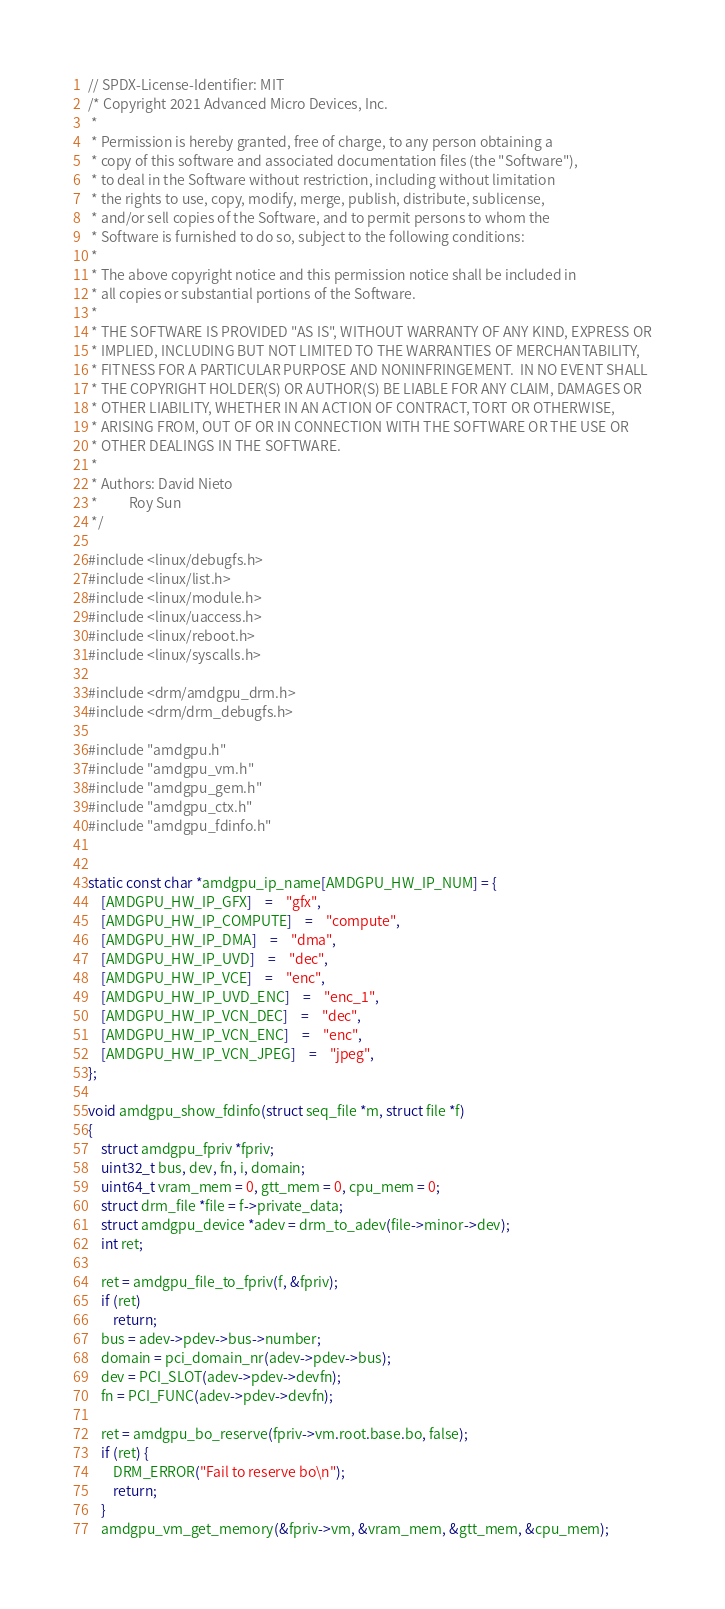<code> <loc_0><loc_0><loc_500><loc_500><_C_>// SPDX-License-Identifier: MIT
/* Copyright 2021 Advanced Micro Devices, Inc.
 *
 * Permission is hereby granted, free of charge, to any person obtaining a
 * copy of this software and associated documentation files (the "Software"),
 * to deal in the Software without restriction, including without limitation
 * the rights to use, copy, modify, merge, publish, distribute, sublicense,
 * and/or sell copies of the Software, and to permit persons to whom the
 * Software is furnished to do so, subject to the following conditions:
 *
 * The above copyright notice and this permission notice shall be included in
 * all copies or substantial portions of the Software.
 *
 * THE SOFTWARE IS PROVIDED "AS IS", WITHOUT WARRANTY OF ANY KIND, EXPRESS OR
 * IMPLIED, INCLUDING BUT NOT LIMITED TO THE WARRANTIES OF MERCHANTABILITY,
 * FITNESS FOR A PARTICULAR PURPOSE AND NONINFRINGEMENT.  IN NO EVENT SHALL
 * THE COPYRIGHT HOLDER(S) OR AUTHOR(S) BE LIABLE FOR ANY CLAIM, DAMAGES OR
 * OTHER LIABILITY, WHETHER IN AN ACTION OF CONTRACT, TORT OR OTHERWISE,
 * ARISING FROM, OUT OF OR IN CONNECTION WITH THE SOFTWARE OR THE USE OR
 * OTHER DEALINGS IN THE SOFTWARE.
 *
 * Authors: David Nieto
 *          Roy Sun
 */

#include <linux/debugfs.h>
#include <linux/list.h>
#include <linux/module.h>
#include <linux/uaccess.h>
#include <linux/reboot.h>
#include <linux/syscalls.h>

#include <drm/amdgpu_drm.h>
#include <drm/drm_debugfs.h>

#include "amdgpu.h"
#include "amdgpu_vm.h"
#include "amdgpu_gem.h"
#include "amdgpu_ctx.h"
#include "amdgpu_fdinfo.h"


static const char *amdgpu_ip_name[AMDGPU_HW_IP_NUM] = {
	[AMDGPU_HW_IP_GFX]	=	"gfx",
	[AMDGPU_HW_IP_COMPUTE]	=	"compute",
	[AMDGPU_HW_IP_DMA]	=	"dma",
	[AMDGPU_HW_IP_UVD]	=	"dec",
	[AMDGPU_HW_IP_VCE]	=	"enc",
	[AMDGPU_HW_IP_UVD_ENC]	=	"enc_1",
	[AMDGPU_HW_IP_VCN_DEC]	=	"dec",
	[AMDGPU_HW_IP_VCN_ENC]	=	"enc",
	[AMDGPU_HW_IP_VCN_JPEG]	=	"jpeg",
};

void amdgpu_show_fdinfo(struct seq_file *m, struct file *f)
{
	struct amdgpu_fpriv *fpriv;
	uint32_t bus, dev, fn, i, domain;
	uint64_t vram_mem = 0, gtt_mem = 0, cpu_mem = 0;
	struct drm_file *file = f->private_data;
	struct amdgpu_device *adev = drm_to_adev(file->minor->dev);
	int ret;

	ret = amdgpu_file_to_fpriv(f, &fpriv);
	if (ret)
		return;
	bus = adev->pdev->bus->number;
	domain = pci_domain_nr(adev->pdev->bus);
	dev = PCI_SLOT(adev->pdev->devfn);
	fn = PCI_FUNC(adev->pdev->devfn);

	ret = amdgpu_bo_reserve(fpriv->vm.root.base.bo, false);
	if (ret) {
		DRM_ERROR("Fail to reserve bo\n");
		return;
	}
	amdgpu_vm_get_memory(&fpriv->vm, &vram_mem, &gtt_mem, &cpu_mem);</code> 